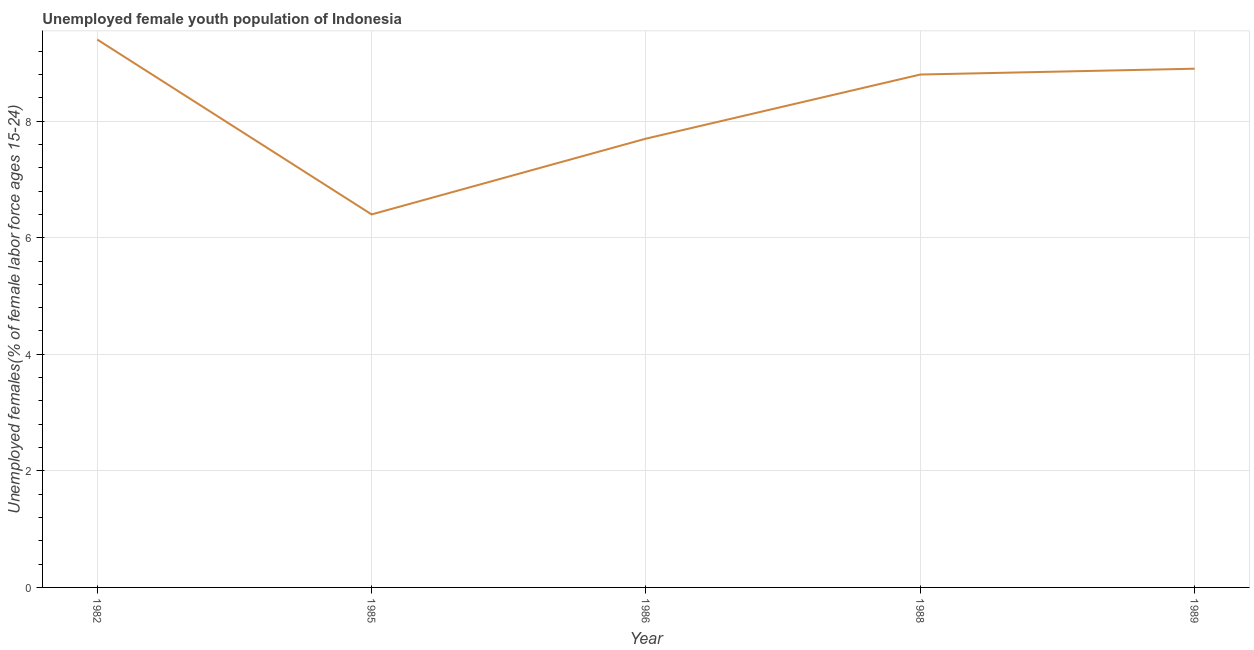What is the unemployed female youth in 1988?
Ensure brevity in your answer.  8.8. Across all years, what is the maximum unemployed female youth?
Your answer should be very brief. 9.4. Across all years, what is the minimum unemployed female youth?
Make the answer very short. 6.4. In which year was the unemployed female youth minimum?
Offer a very short reply. 1985. What is the sum of the unemployed female youth?
Provide a short and direct response. 41.2. What is the difference between the unemployed female youth in 1985 and 1989?
Keep it short and to the point. -2.5. What is the average unemployed female youth per year?
Ensure brevity in your answer.  8.24. What is the median unemployed female youth?
Your answer should be very brief. 8.8. What is the ratio of the unemployed female youth in 1988 to that in 1989?
Make the answer very short. 0.99. Is the unemployed female youth in 1986 less than that in 1989?
Offer a terse response. Yes. Is the difference between the unemployed female youth in 1988 and 1989 greater than the difference between any two years?
Give a very brief answer. No. What is the difference between the highest and the second highest unemployed female youth?
Ensure brevity in your answer.  0.5. What is the difference between the highest and the lowest unemployed female youth?
Offer a terse response. 3. In how many years, is the unemployed female youth greater than the average unemployed female youth taken over all years?
Your answer should be compact. 3. Does the unemployed female youth monotonically increase over the years?
Make the answer very short. No. How many years are there in the graph?
Keep it short and to the point. 5. Are the values on the major ticks of Y-axis written in scientific E-notation?
Provide a short and direct response. No. Does the graph contain grids?
Your response must be concise. Yes. What is the title of the graph?
Your response must be concise. Unemployed female youth population of Indonesia. What is the label or title of the X-axis?
Ensure brevity in your answer.  Year. What is the label or title of the Y-axis?
Make the answer very short. Unemployed females(% of female labor force ages 15-24). What is the Unemployed females(% of female labor force ages 15-24) in 1982?
Your answer should be compact. 9.4. What is the Unemployed females(% of female labor force ages 15-24) in 1985?
Offer a terse response. 6.4. What is the Unemployed females(% of female labor force ages 15-24) of 1986?
Your answer should be compact. 7.7. What is the Unemployed females(% of female labor force ages 15-24) in 1988?
Your response must be concise. 8.8. What is the Unemployed females(% of female labor force ages 15-24) of 1989?
Keep it short and to the point. 8.9. What is the difference between the Unemployed females(% of female labor force ages 15-24) in 1982 and 1985?
Keep it short and to the point. 3. What is the difference between the Unemployed females(% of female labor force ages 15-24) in 1982 and 1986?
Give a very brief answer. 1.7. What is the difference between the Unemployed females(% of female labor force ages 15-24) in 1982 and 1989?
Give a very brief answer. 0.5. What is the difference between the Unemployed females(% of female labor force ages 15-24) in 1985 and 1988?
Provide a short and direct response. -2.4. What is the difference between the Unemployed females(% of female labor force ages 15-24) in 1986 and 1989?
Your response must be concise. -1.2. What is the difference between the Unemployed females(% of female labor force ages 15-24) in 1988 and 1989?
Your answer should be very brief. -0.1. What is the ratio of the Unemployed females(% of female labor force ages 15-24) in 1982 to that in 1985?
Keep it short and to the point. 1.47. What is the ratio of the Unemployed females(% of female labor force ages 15-24) in 1982 to that in 1986?
Offer a very short reply. 1.22. What is the ratio of the Unemployed females(% of female labor force ages 15-24) in 1982 to that in 1988?
Offer a terse response. 1.07. What is the ratio of the Unemployed females(% of female labor force ages 15-24) in 1982 to that in 1989?
Your answer should be very brief. 1.06. What is the ratio of the Unemployed females(% of female labor force ages 15-24) in 1985 to that in 1986?
Your answer should be compact. 0.83. What is the ratio of the Unemployed females(% of female labor force ages 15-24) in 1985 to that in 1988?
Your answer should be very brief. 0.73. What is the ratio of the Unemployed females(% of female labor force ages 15-24) in 1985 to that in 1989?
Make the answer very short. 0.72. What is the ratio of the Unemployed females(% of female labor force ages 15-24) in 1986 to that in 1989?
Make the answer very short. 0.86. What is the ratio of the Unemployed females(% of female labor force ages 15-24) in 1988 to that in 1989?
Your answer should be very brief. 0.99. 